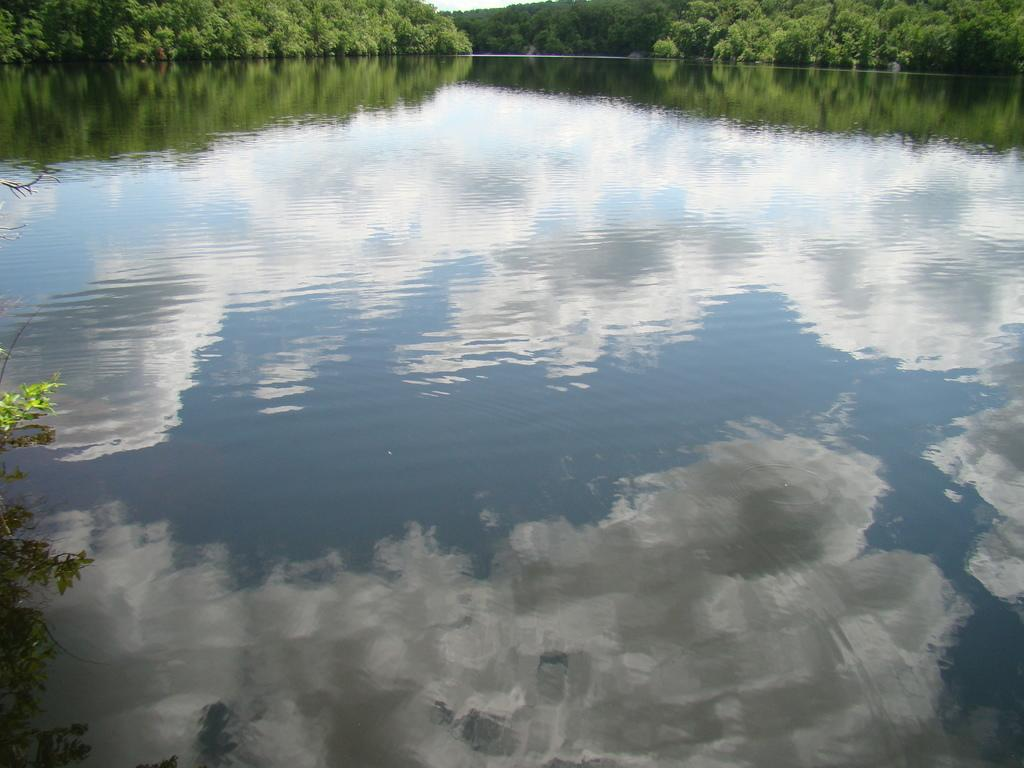What can be seen in the water in the image? There is a reflection of clouds in the water. What type of vegetation is present in the image? There are trees and plants in the image. How does the toothpaste affect the prison in the image? There is no toothpaste or prison present in the image. 